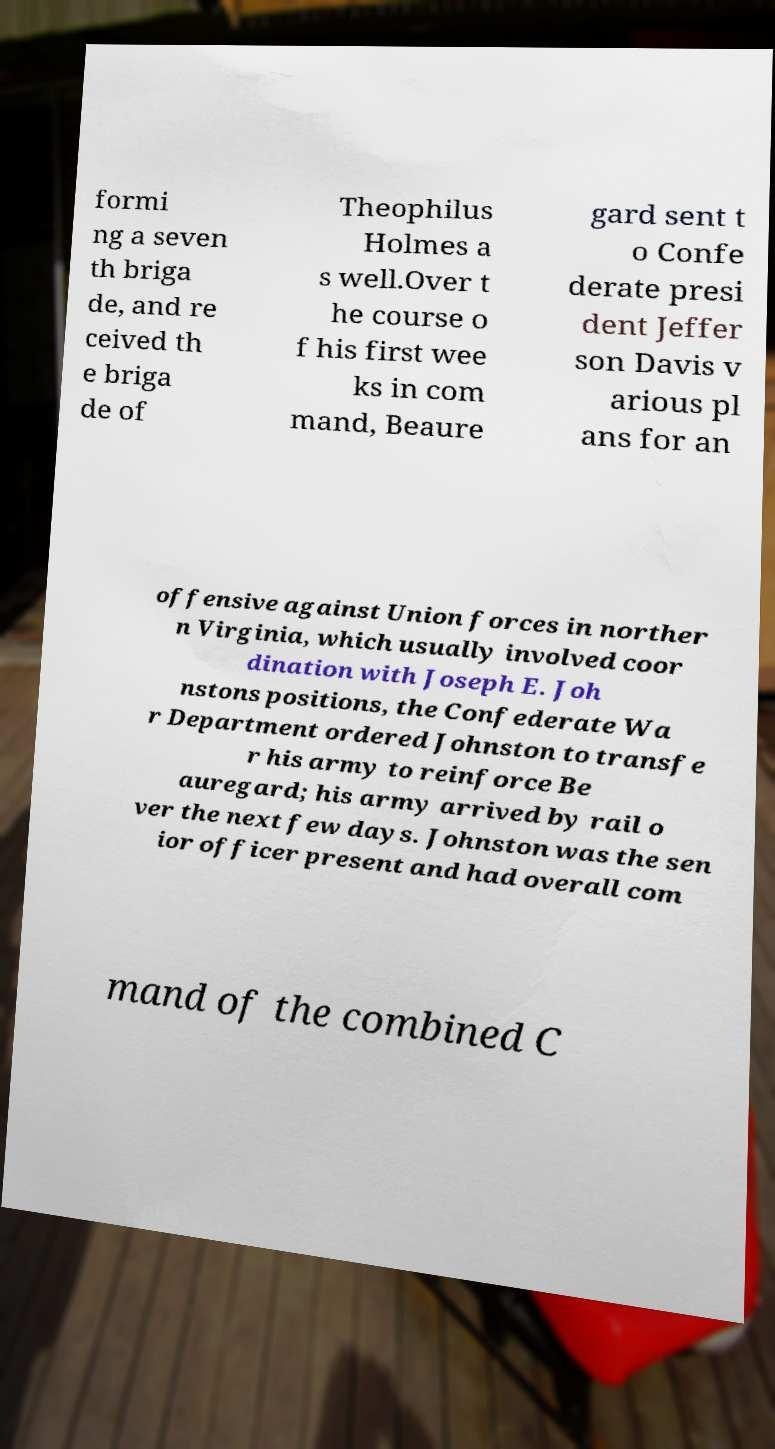There's text embedded in this image that I need extracted. Can you transcribe it verbatim? formi ng a seven th briga de, and re ceived th e briga de of Theophilus Holmes a s well.Over t he course o f his first wee ks in com mand, Beaure gard sent t o Confe derate presi dent Jeffer son Davis v arious pl ans for an offensive against Union forces in norther n Virginia, which usually involved coor dination with Joseph E. Joh nstons positions, the Confederate Wa r Department ordered Johnston to transfe r his army to reinforce Be auregard; his army arrived by rail o ver the next few days. Johnston was the sen ior officer present and had overall com mand of the combined C 